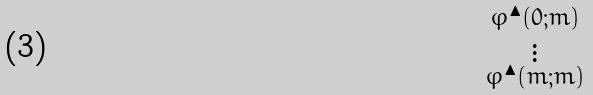<formula> <loc_0><loc_0><loc_500><loc_500>\begin{smallmatrix} \varphi ^ { \blacktriangle } ( 0 ; m ) \\ \vdots \\ \varphi ^ { \blacktriangle } ( m ; m ) \end{smallmatrix}</formula> 